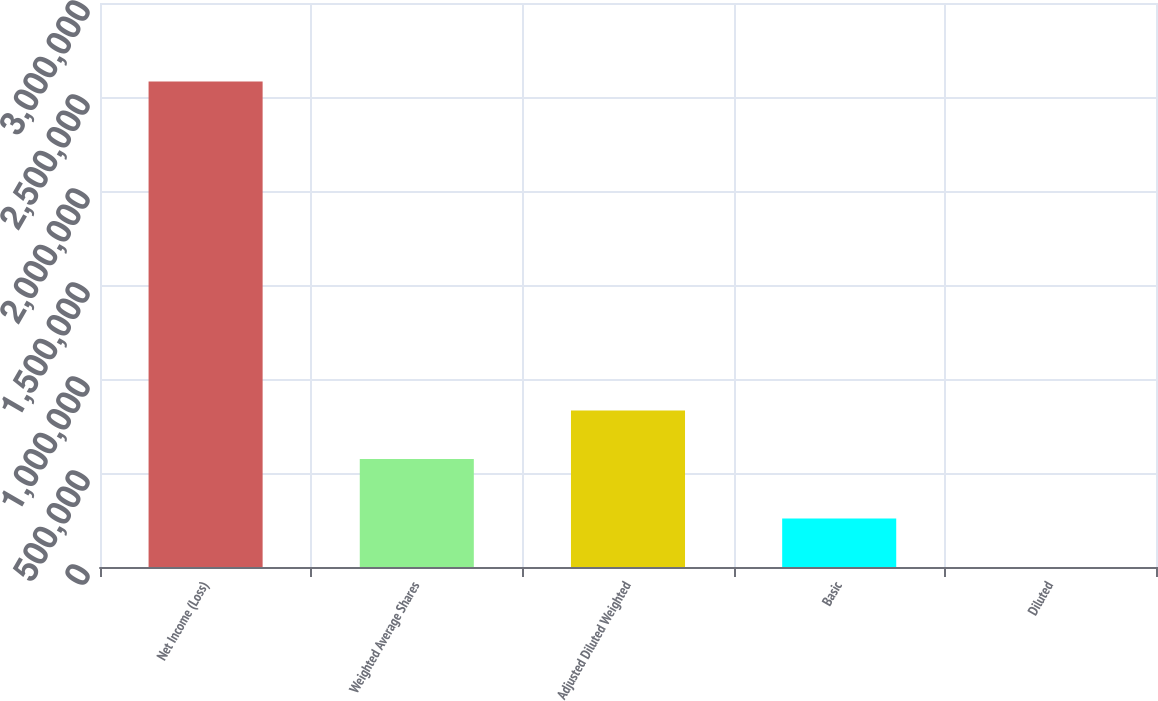Convert chart to OTSL. <chart><loc_0><loc_0><loc_500><loc_500><bar_chart><fcel>Net Income (Loss)<fcel>Weighted Average Shares<fcel>Adjusted Diluted Weighted<fcel>Basic<fcel>Diluted<nl><fcel>2.58258e+06<fcel>574620<fcel>832877<fcel>258262<fcel>4.46<nl></chart> 